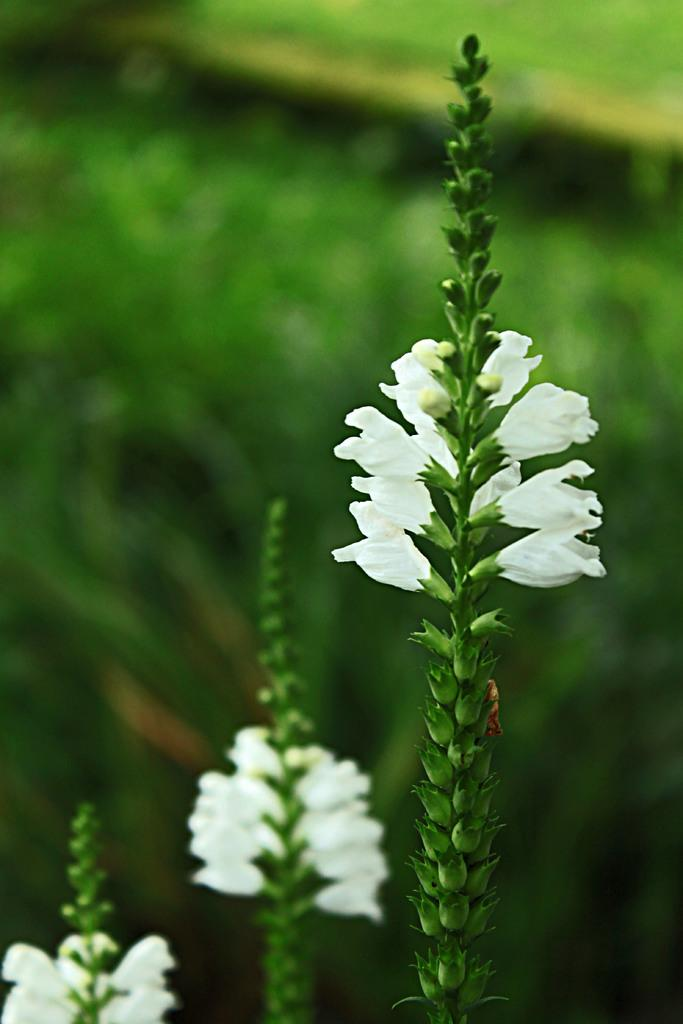How many plants are in the image? There are three plants in the image. What color are the flowers on the plants? The flowers on the plants are white. Can you describe the plants in the background? The plants in the background are not clearly visible, so it is difficult to describe them. What type of pie is being served in the park in the image? There is no pie or park present in the image; it features three plants with white flowers. 